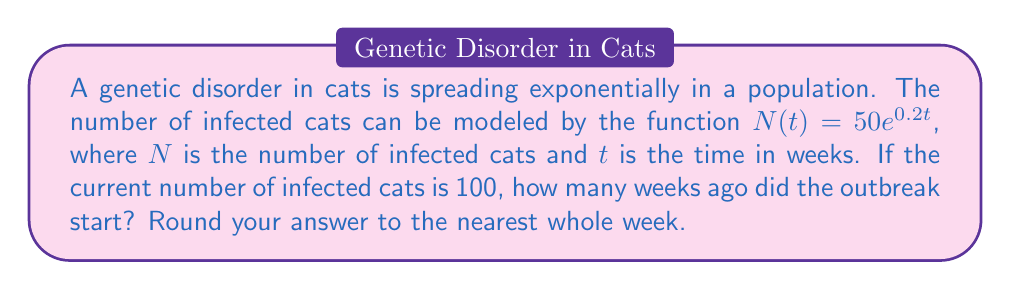Can you answer this question? To solve this problem, we need to use the given exponential function and the current number of infected cats. Let's approach this step-by-step:

1) The given function is $N(t) = 50e^{0.2t}$

2) We know that the current number of infected cats is 100. So we can set up the equation:

   $100 = 50e^{0.2t}$

3) To solve for $t$, we first divide both sides by 50:

   $2 = e^{0.2t}$

4) Now, we take the natural logarithm of both sides:

   $\ln(2) = \ln(e^{0.2t})$

5) Using the property of logarithms that $\ln(e^x) = x$, we get:

   $\ln(2) = 0.2t$

6) Now we can solve for $t$:

   $t = \frac{\ln(2)}{0.2}$

7) Using a calculator:

   $t \approx 3.47$ weeks

8) Rounding to the nearest whole week:

   $t \approx 3$ weeks
Answer: The outbreak started approximately 3 weeks ago. 